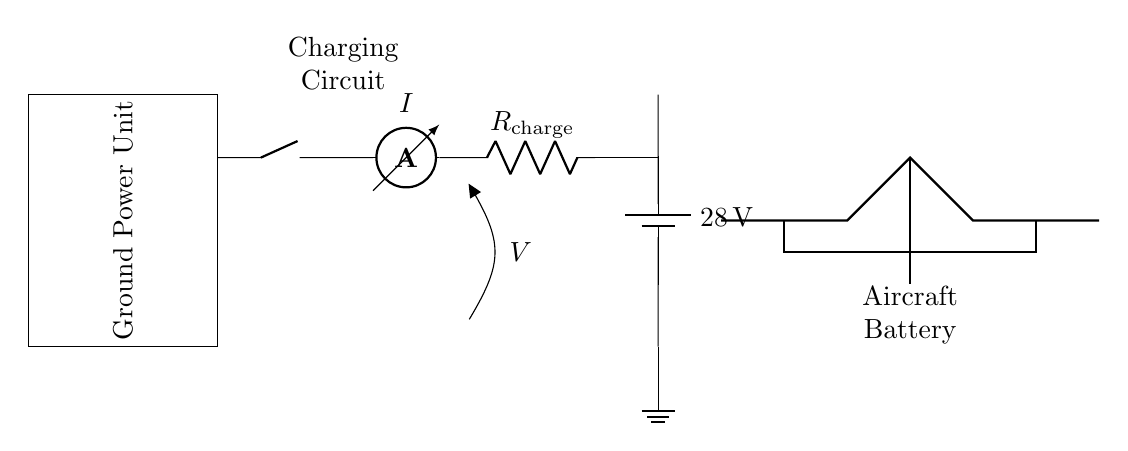What is the voltage of the battery? The diagram shows a battery labeled with the voltage of 28 volts. This indicates the potential difference provided by the battery for the charging circuit.
Answer: 28 volts What component is used to measure current in this circuit? The ammeter is the component specifically designated for measuring current, as indicated by its label in the circuit diagram.
Answer: Ammeter What does the resistor in the circuit represent? The resistor labeled as R charge indicates the resistance through which the charging current flows. Resistors control the flow of current in a circuit.
Answer: R charge What is the role of the ground in this circuit? The ground is used as a reference point for the circuit. It establishes a common return path for electric current, helping to define the potential of other points in the circuit.
Answer: Reference point Why is a voltmeter included in this circuit? The voltmeter is included to measure the voltage across specific points in the circuit, which can help monitor voltage levels during the charging process. It provides important information about the state of the charging.
Answer: To measure voltage How does the circuit connect to the aircraft battery? The circuit connects to the aircraft battery through the specified terminals, which are visually indicated in the drawing. The voltage from the ground power unit charges the aircraft battery when connected properly.
Answer: Through specified terminals What does the 'nos' component in the diagram indicate? The 'nos' in the circuit represents a normally open switch, indicating that the switch is open at this connection. It is part of the charging circuit designed to control the charging process by allowing or preventing current flow.
Answer: Normally open switch 